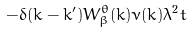<formula> <loc_0><loc_0><loc_500><loc_500>- \delta ( k - k ^ { \prime } ) W _ { \beta } ^ { \theta } ( k ) \nu ( k ) \lambda ^ { 2 } t</formula> 